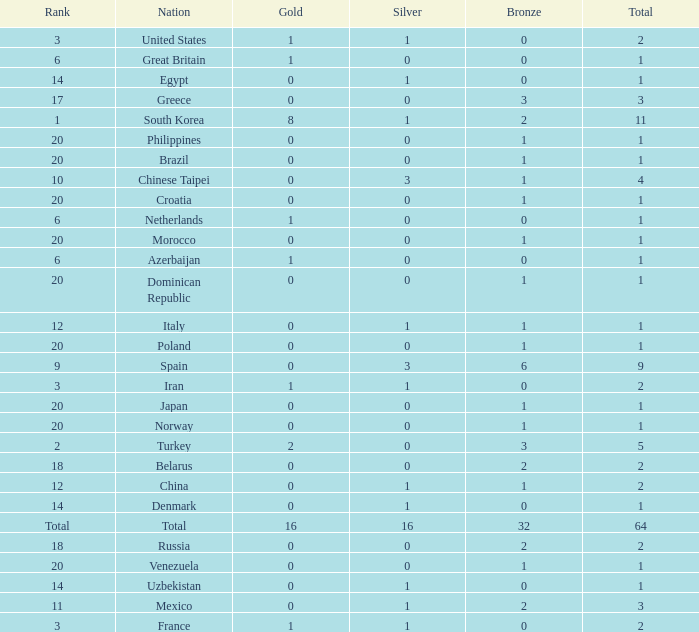How many total silvers does Russia have? 1.0. 